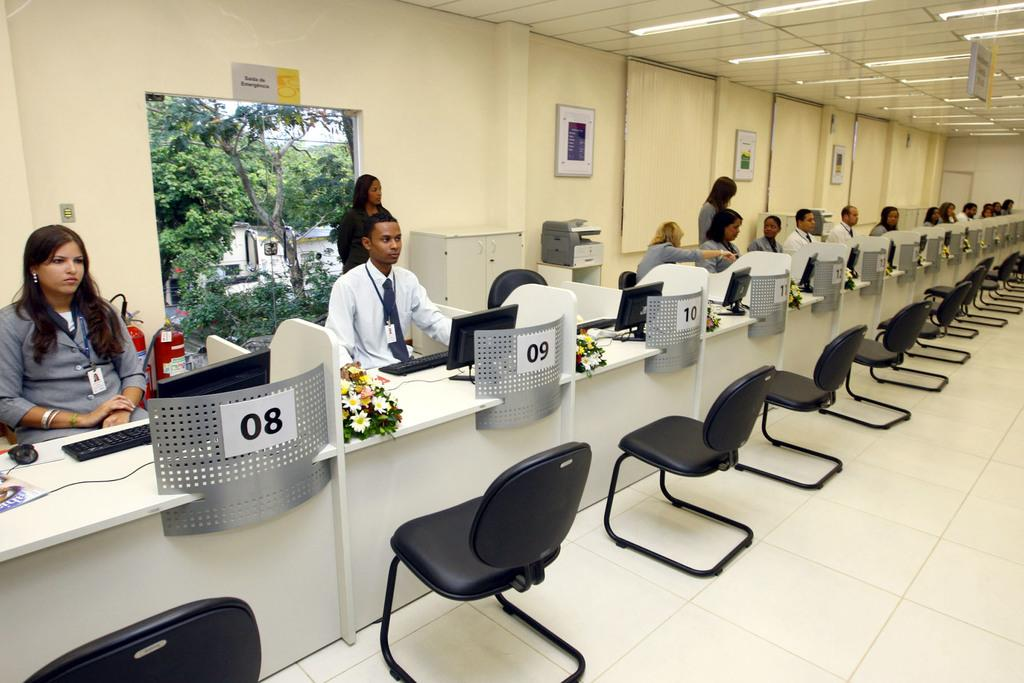What type of structure can be seen in the image? There is a wall in the image. What decorative items are present on the wall? There are photo frames in the image. What type of furniture is visible in the image? There are chairs in the image. What are the people in the image doing? There are people sitting on the chairs. What type of animal can be seen in the image? There is a mouse in the image. What type of equipment is present in the image? There is a keyboard and a laptop in the image. What type of floral arrangement is present in the image? There are bouquets in the image. What type of field can be seen in the image? There is no field present in the image. What type of porter is assisting the people in the image? There is no porter present in the image. 